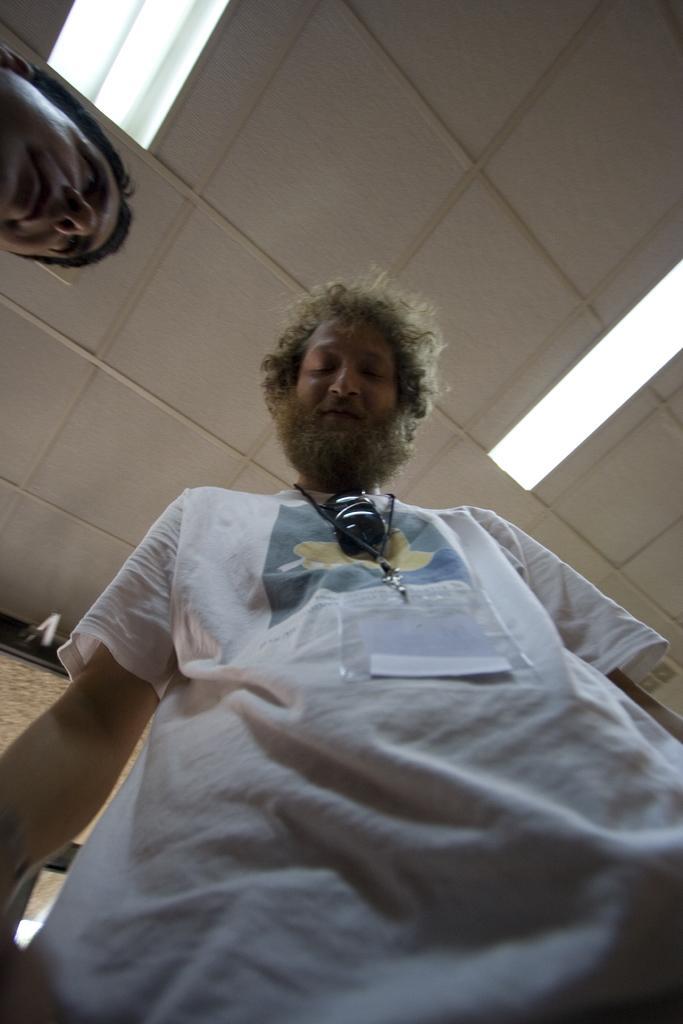How would you summarize this image in a sentence or two? In this image, there is a person standing and wearing clothes. There is a ceiling at the top of the image contains lights. There is an another person head in top left of the image. 